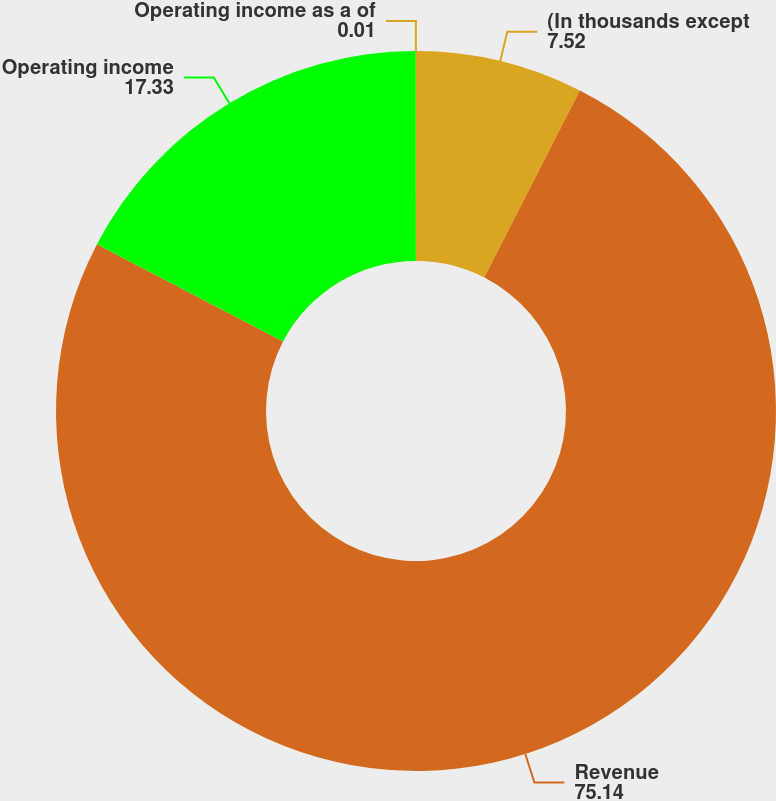<chart> <loc_0><loc_0><loc_500><loc_500><pie_chart><fcel>(In thousands except<fcel>Revenue<fcel>Operating income<fcel>Operating income as a of<nl><fcel>7.52%<fcel>75.14%<fcel>17.33%<fcel>0.01%<nl></chart> 